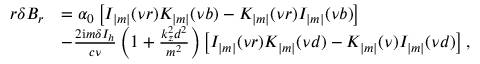Convert formula to latex. <formula><loc_0><loc_0><loc_500><loc_500>\begin{array} { r } { \begin{array} { r l } { r \delta B _ { r } } & { = \alpha _ { 0 } \left [ I _ { | m | } ( \nu r ) K _ { | m | } ( \nu b ) - K _ { | m | } ( \nu r ) I _ { | m | } ( \nu b ) \right ] } \\ & { - \frac { 2 i m \delta I _ { h } } { c \nu } \left ( 1 + \frac { k _ { z } ^ { 2 } d ^ { 2 } } { m ^ { 2 } } \right ) \left [ I _ { | m | } ( \nu r ) K _ { | m | } ( \nu d ) - K _ { | m | } ( \nu ) I _ { | m | } ( \nu d ) \right ] , } \end{array} } \end{array}</formula> 